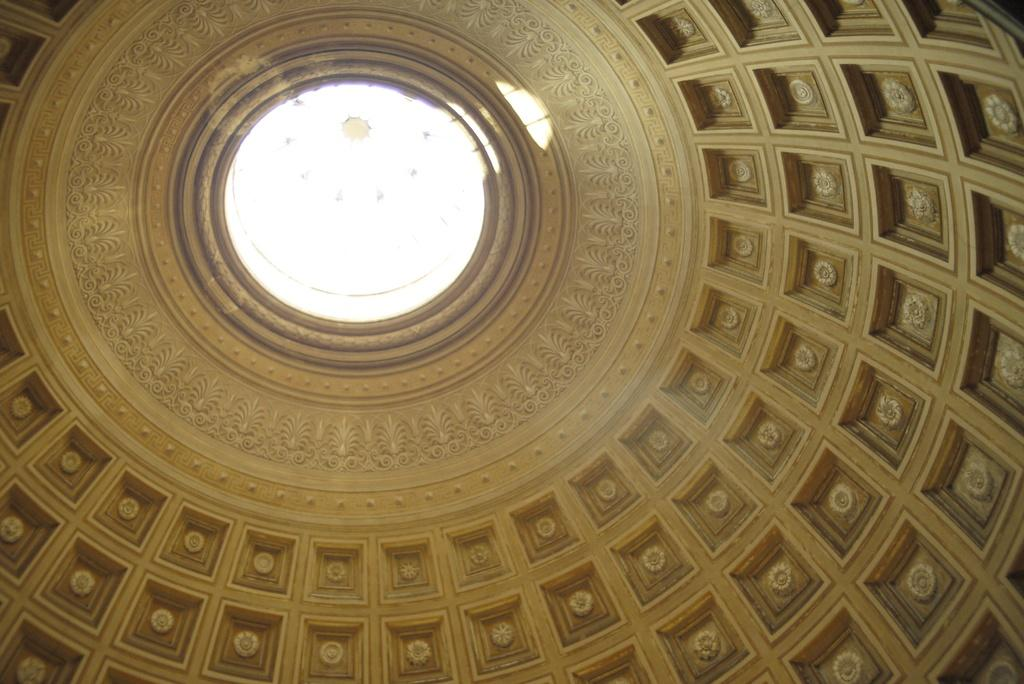What famous landmark can be seen in the image? The dome of the Vatican Museum is visible in the image. Can you describe the architectural style of the landmark? The Vatican Museum is known for its Renaissance and Baroque architecture. What might be the significance of this landmark? The Vatican Museum is a significant cultural and religious site, housing a vast collection of art and artifacts. How many bananas are hanging from the dome in the image? There are no bananas present in the image; it features the dome of the Vatican Museum. 